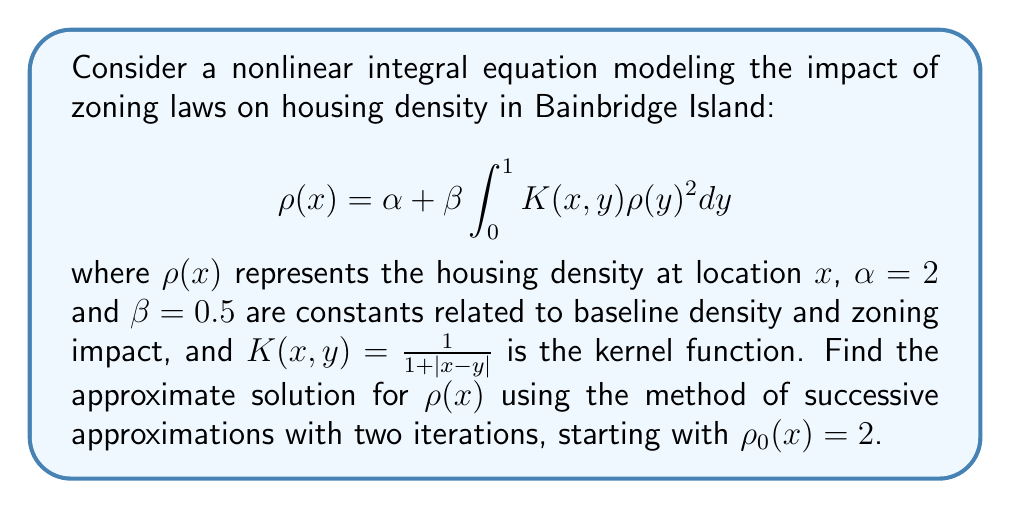Teach me how to tackle this problem. To solve this nonlinear integral equation using the method of successive approximations, we follow these steps:

1) Start with the initial approximation $\rho_0(x) = 2$.

2) For the first iteration, substitute $\rho_0(x)$ into the right-hand side of the equation:

   $$\rho_1(x) = 2 + 0.5 \int_0^1 \frac{1}{1 + |x-y|} \cdot 2^2 dy$$

   $$\rho_1(x) = 2 + 2 \int_0^1 \frac{1}{1 + |x-y|} dy$$

3) Evaluate the integral:

   For $x \leq y$: $\int_x^1 \frac{1}{1 + (y-x)} dy = \ln(2-x)$
   For $x > y$: $\int_0^x \frac{1}{1 + (x-y)} dy = \ln(1+x)$

   Combining these:

   $$\rho_1(x) = 2 + 2[\ln(2-x) + \ln(1+x)] = 2 + 2\ln(2+x-x^2)$$

4) For the second iteration, use $\rho_1(x)$ in the right-hand side:

   $$\rho_2(x) = 2 + 0.5 \int_0^1 \frac{1}{1 + |x-y|} [2 + 2\ln(2+y-y^2)]^2 dy$$

5) Expand the squared term:

   $$\rho_2(x) = 2 + 0.5 \int_0^1 \frac{1}{1 + |x-y|} [4 + 8\ln(2+y-y^2) + 4\ln^2(2+y-y^2)] dy$$

6) This integral is complex and doesn't have a simple closed-form solution. In practice, it would be evaluated numerically for specific values of $x$.

The approximate solution after two iterations is $\rho_2(x)$.
Answer: $\rho_2(x) = 2 + 0.5 \int_0^1 \frac{1}{1 + |x-y|} [4 + 8\ln(2+y-y^2) + 4\ln^2(2+y-y^2)] dy$ 